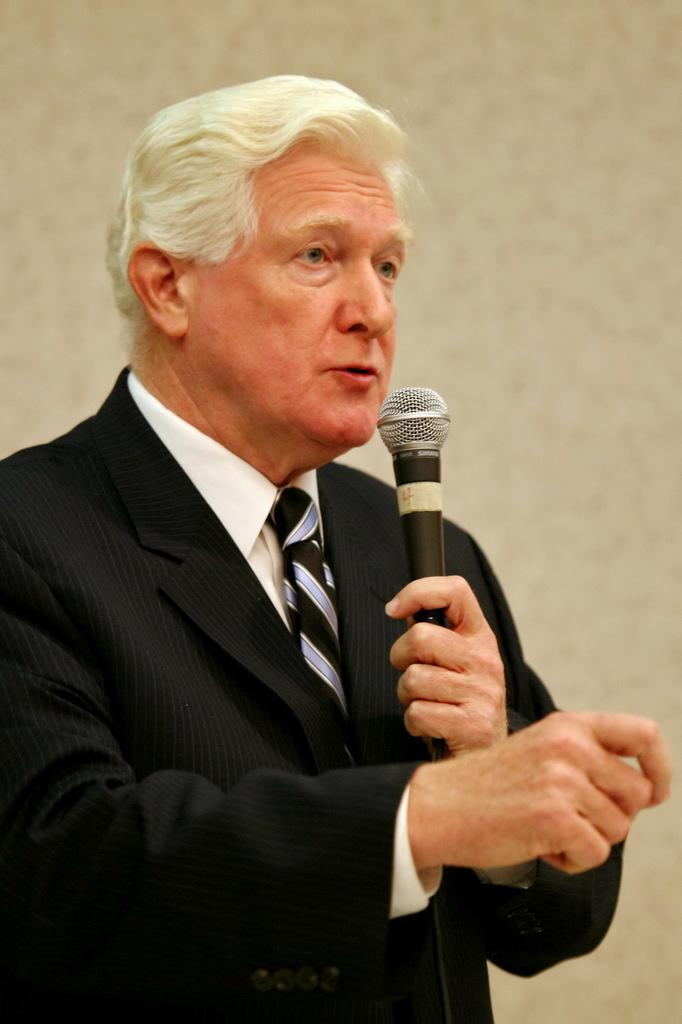Who is the main subject in the image? There is a man in the image. What is the man wearing? The man is wearing a white shirt and a black blazer. What is the man holding in his hand? The man is holding a microphone in his hand. What is the man doing with the microphone? The man is talking into the microphone. Can you describe the man's appearance? The man appears to be old. What type of patch can be seen on the man's shirt in the image? There is no patch visible on the man's shirt in the image. 